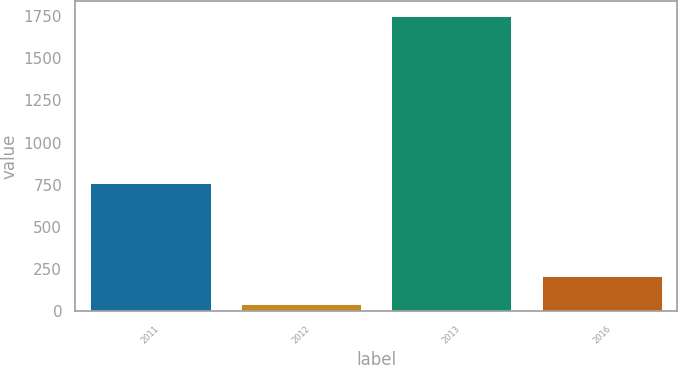<chart> <loc_0><loc_0><loc_500><loc_500><bar_chart><fcel>2011<fcel>2012<fcel>2013<fcel>2016<nl><fcel>760<fcel>40<fcel>1750<fcel>211<nl></chart> 